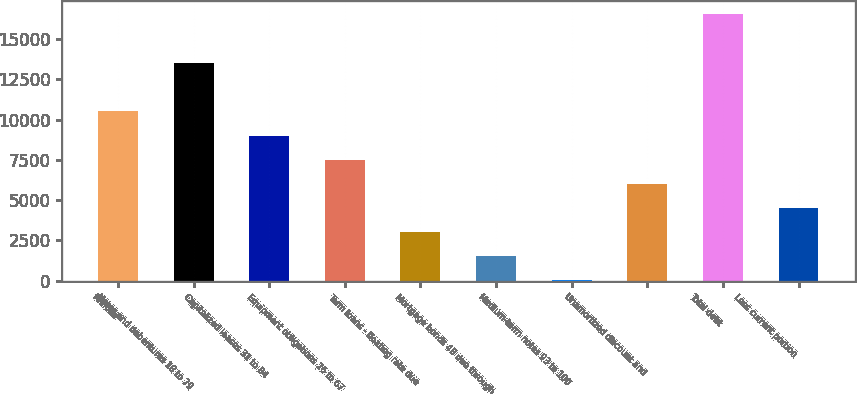Convert chart. <chart><loc_0><loc_0><loc_500><loc_500><bar_chart><fcel>Millions<fcel>Notes and debentures 18 to 79<fcel>Capitalized leases 31 to 84<fcel>Equipment obligations 26 to 67<fcel>Term loans - floating rate due<fcel>Mortgage bonds 48 due through<fcel>Medium-term notes 93 to 100<fcel>Unamortized discount and<fcel>Total debt<fcel>Less current portion<nl><fcel>10511.8<fcel>13547<fcel>9013.4<fcel>7515<fcel>3019.8<fcel>1521.4<fcel>23<fcel>6016.6<fcel>16543.8<fcel>4518.2<nl></chart> 